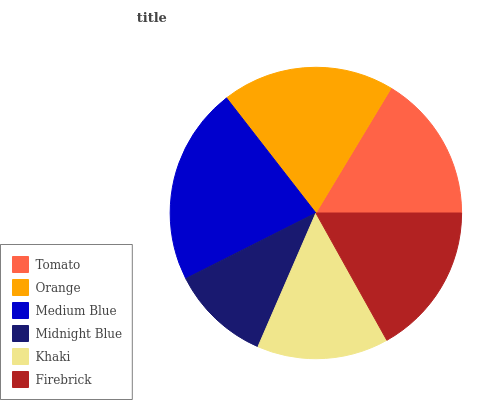Is Midnight Blue the minimum?
Answer yes or no. Yes. Is Medium Blue the maximum?
Answer yes or no. Yes. Is Orange the minimum?
Answer yes or no. No. Is Orange the maximum?
Answer yes or no. No. Is Orange greater than Tomato?
Answer yes or no. Yes. Is Tomato less than Orange?
Answer yes or no. Yes. Is Tomato greater than Orange?
Answer yes or no. No. Is Orange less than Tomato?
Answer yes or no. No. Is Firebrick the high median?
Answer yes or no. Yes. Is Tomato the low median?
Answer yes or no. Yes. Is Khaki the high median?
Answer yes or no. No. Is Medium Blue the low median?
Answer yes or no. No. 